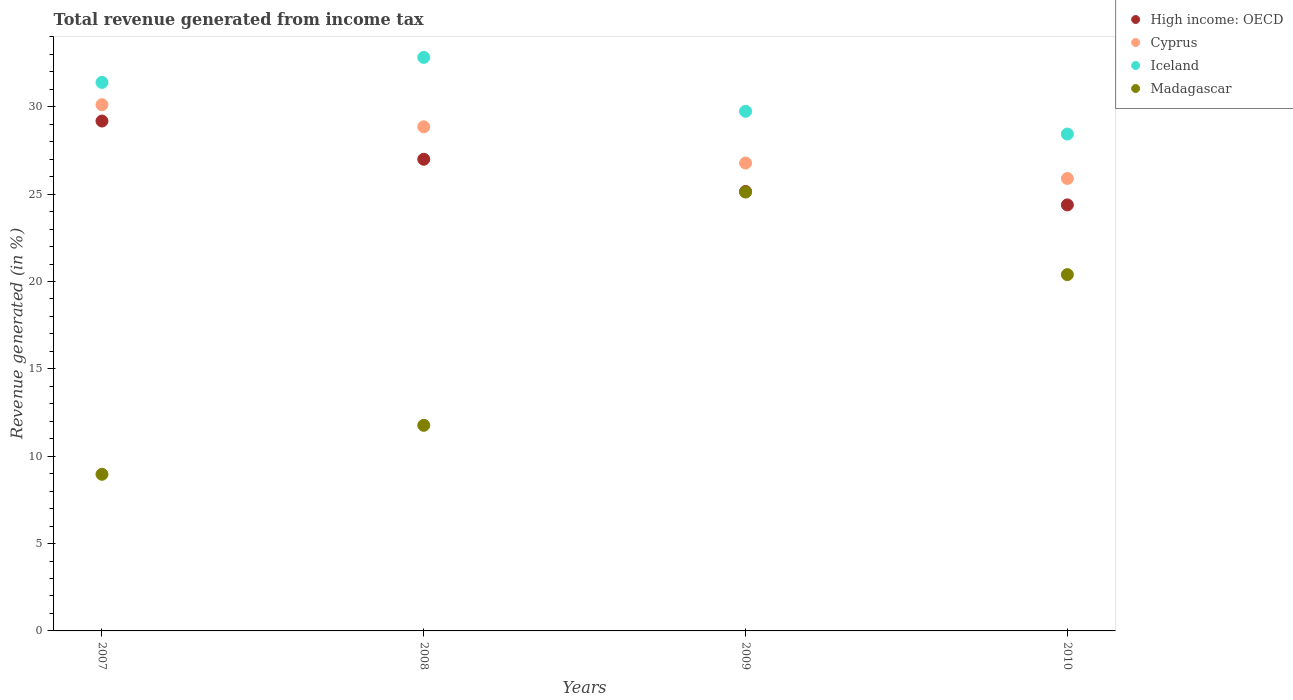Is the number of dotlines equal to the number of legend labels?
Offer a terse response. Yes. What is the total revenue generated in Cyprus in 2009?
Your response must be concise. 26.78. Across all years, what is the maximum total revenue generated in High income: OECD?
Provide a short and direct response. 29.19. Across all years, what is the minimum total revenue generated in High income: OECD?
Give a very brief answer. 24.39. In which year was the total revenue generated in Iceland maximum?
Provide a succinct answer. 2008. What is the total total revenue generated in Iceland in the graph?
Make the answer very short. 122.41. What is the difference between the total revenue generated in Cyprus in 2007 and that in 2010?
Offer a terse response. 4.22. What is the difference between the total revenue generated in High income: OECD in 2009 and the total revenue generated in Iceland in 2007?
Provide a short and direct response. -6.24. What is the average total revenue generated in Iceland per year?
Keep it short and to the point. 30.6. In the year 2010, what is the difference between the total revenue generated in Madagascar and total revenue generated in High income: OECD?
Your answer should be compact. -3.99. What is the ratio of the total revenue generated in Cyprus in 2007 to that in 2010?
Provide a short and direct response. 1.16. Is the total revenue generated in Iceland in 2007 less than that in 2010?
Ensure brevity in your answer.  No. What is the difference between the highest and the second highest total revenue generated in Madagascar?
Offer a terse response. 4.73. What is the difference between the highest and the lowest total revenue generated in Madagascar?
Offer a terse response. 16.16. Is the sum of the total revenue generated in Iceland in 2009 and 2010 greater than the maximum total revenue generated in Cyprus across all years?
Make the answer very short. Yes. How many dotlines are there?
Provide a short and direct response. 4. How many years are there in the graph?
Your answer should be very brief. 4. What is the difference between two consecutive major ticks on the Y-axis?
Provide a short and direct response. 5. Are the values on the major ticks of Y-axis written in scientific E-notation?
Ensure brevity in your answer.  No. Does the graph contain any zero values?
Your response must be concise. No. How many legend labels are there?
Provide a succinct answer. 4. How are the legend labels stacked?
Keep it short and to the point. Vertical. What is the title of the graph?
Give a very brief answer. Total revenue generated from income tax. Does "Namibia" appear as one of the legend labels in the graph?
Offer a terse response. No. What is the label or title of the X-axis?
Your response must be concise. Years. What is the label or title of the Y-axis?
Offer a very short reply. Revenue generated (in %). What is the Revenue generated (in %) in High income: OECD in 2007?
Offer a terse response. 29.19. What is the Revenue generated (in %) in Cyprus in 2007?
Provide a short and direct response. 30.12. What is the Revenue generated (in %) in Iceland in 2007?
Provide a short and direct response. 31.4. What is the Revenue generated (in %) in Madagascar in 2007?
Keep it short and to the point. 8.97. What is the Revenue generated (in %) of High income: OECD in 2008?
Offer a terse response. 27. What is the Revenue generated (in %) of Cyprus in 2008?
Your answer should be compact. 28.86. What is the Revenue generated (in %) in Iceland in 2008?
Provide a succinct answer. 32.83. What is the Revenue generated (in %) of Madagascar in 2008?
Your response must be concise. 11.77. What is the Revenue generated (in %) in High income: OECD in 2009?
Provide a succinct answer. 25.15. What is the Revenue generated (in %) in Cyprus in 2009?
Offer a terse response. 26.78. What is the Revenue generated (in %) in Iceland in 2009?
Your answer should be compact. 29.74. What is the Revenue generated (in %) of Madagascar in 2009?
Give a very brief answer. 25.12. What is the Revenue generated (in %) of High income: OECD in 2010?
Your answer should be compact. 24.39. What is the Revenue generated (in %) in Cyprus in 2010?
Keep it short and to the point. 25.9. What is the Revenue generated (in %) of Iceland in 2010?
Make the answer very short. 28.44. What is the Revenue generated (in %) of Madagascar in 2010?
Your response must be concise. 20.39. Across all years, what is the maximum Revenue generated (in %) in High income: OECD?
Give a very brief answer. 29.19. Across all years, what is the maximum Revenue generated (in %) in Cyprus?
Give a very brief answer. 30.12. Across all years, what is the maximum Revenue generated (in %) of Iceland?
Provide a succinct answer. 32.83. Across all years, what is the maximum Revenue generated (in %) of Madagascar?
Make the answer very short. 25.12. Across all years, what is the minimum Revenue generated (in %) in High income: OECD?
Provide a short and direct response. 24.39. Across all years, what is the minimum Revenue generated (in %) of Cyprus?
Provide a succinct answer. 25.9. Across all years, what is the minimum Revenue generated (in %) of Iceland?
Provide a short and direct response. 28.44. Across all years, what is the minimum Revenue generated (in %) of Madagascar?
Your response must be concise. 8.97. What is the total Revenue generated (in %) in High income: OECD in the graph?
Offer a very short reply. 105.72. What is the total Revenue generated (in %) in Cyprus in the graph?
Offer a terse response. 111.66. What is the total Revenue generated (in %) of Iceland in the graph?
Provide a short and direct response. 122.41. What is the total Revenue generated (in %) in Madagascar in the graph?
Offer a terse response. 66.25. What is the difference between the Revenue generated (in %) in High income: OECD in 2007 and that in 2008?
Make the answer very short. 2.19. What is the difference between the Revenue generated (in %) in Cyprus in 2007 and that in 2008?
Make the answer very short. 1.27. What is the difference between the Revenue generated (in %) in Iceland in 2007 and that in 2008?
Offer a very short reply. -1.43. What is the difference between the Revenue generated (in %) of Madagascar in 2007 and that in 2008?
Your answer should be compact. -2.8. What is the difference between the Revenue generated (in %) in High income: OECD in 2007 and that in 2009?
Give a very brief answer. 4.03. What is the difference between the Revenue generated (in %) of Cyprus in 2007 and that in 2009?
Make the answer very short. 3.34. What is the difference between the Revenue generated (in %) of Iceland in 2007 and that in 2009?
Your answer should be very brief. 1.65. What is the difference between the Revenue generated (in %) in Madagascar in 2007 and that in 2009?
Your answer should be compact. -16.16. What is the difference between the Revenue generated (in %) in High income: OECD in 2007 and that in 2010?
Provide a short and direct response. 4.8. What is the difference between the Revenue generated (in %) in Cyprus in 2007 and that in 2010?
Give a very brief answer. 4.22. What is the difference between the Revenue generated (in %) of Iceland in 2007 and that in 2010?
Give a very brief answer. 2.96. What is the difference between the Revenue generated (in %) of Madagascar in 2007 and that in 2010?
Make the answer very short. -11.43. What is the difference between the Revenue generated (in %) in High income: OECD in 2008 and that in 2009?
Keep it short and to the point. 1.84. What is the difference between the Revenue generated (in %) of Cyprus in 2008 and that in 2009?
Provide a short and direct response. 2.07. What is the difference between the Revenue generated (in %) in Iceland in 2008 and that in 2009?
Keep it short and to the point. 3.08. What is the difference between the Revenue generated (in %) in Madagascar in 2008 and that in 2009?
Your answer should be compact. -13.35. What is the difference between the Revenue generated (in %) in High income: OECD in 2008 and that in 2010?
Ensure brevity in your answer.  2.61. What is the difference between the Revenue generated (in %) of Cyprus in 2008 and that in 2010?
Provide a succinct answer. 2.96. What is the difference between the Revenue generated (in %) in Iceland in 2008 and that in 2010?
Your answer should be very brief. 4.39. What is the difference between the Revenue generated (in %) of Madagascar in 2008 and that in 2010?
Your answer should be very brief. -8.63. What is the difference between the Revenue generated (in %) in High income: OECD in 2009 and that in 2010?
Offer a terse response. 0.77. What is the difference between the Revenue generated (in %) in Cyprus in 2009 and that in 2010?
Provide a succinct answer. 0.89. What is the difference between the Revenue generated (in %) in Iceland in 2009 and that in 2010?
Your answer should be very brief. 1.3. What is the difference between the Revenue generated (in %) in Madagascar in 2009 and that in 2010?
Provide a short and direct response. 4.73. What is the difference between the Revenue generated (in %) of High income: OECD in 2007 and the Revenue generated (in %) of Cyprus in 2008?
Give a very brief answer. 0.33. What is the difference between the Revenue generated (in %) in High income: OECD in 2007 and the Revenue generated (in %) in Iceland in 2008?
Provide a succinct answer. -3.64. What is the difference between the Revenue generated (in %) of High income: OECD in 2007 and the Revenue generated (in %) of Madagascar in 2008?
Provide a short and direct response. 17.42. What is the difference between the Revenue generated (in %) of Cyprus in 2007 and the Revenue generated (in %) of Iceland in 2008?
Give a very brief answer. -2.71. What is the difference between the Revenue generated (in %) of Cyprus in 2007 and the Revenue generated (in %) of Madagascar in 2008?
Provide a short and direct response. 18.35. What is the difference between the Revenue generated (in %) in Iceland in 2007 and the Revenue generated (in %) in Madagascar in 2008?
Make the answer very short. 19.63. What is the difference between the Revenue generated (in %) in High income: OECD in 2007 and the Revenue generated (in %) in Cyprus in 2009?
Ensure brevity in your answer.  2.4. What is the difference between the Revenue generated (in %) in High income: OECD in 2007 and the Revenue generated (in %) in Iceland in 2009?
Your answer should be very brief. -0.56. What is the difference between the Revenue generated (in %) of High income: OECD in 2007 and the Revenue generated (in %) of Madagascar in 2009?
Your answer should be compact. 4.06. What is the difference between the Revenue generated (in %) in Cyprus in 2007 and the Revenue generated (in %) in Iceland in 2009?
Make the answer very short. 0.38. What is the difference between the Revenue generated (in %) in Cyprus in 2007 and the Revenue generated (in %) in Madagascar in 2009?
Offer a terse response. 5. What is the difference between the Revenue generated (in %) of Iceland in 2007 and the Revenue generated (in %) of Madagascar in 2009?
Give a very brief answer. 6.28. What is the difference between the Revenue generated (in %) in High income: OECD in 2007 and the Revenue generated (in %) in Cyprus in 2010?
Provide a succinct answer. 3.29. What is the difference between the Revenue generated (in %) in High income: OECD in 2007 and the Revenue generated (in %) in Iceland in 2010?
Provide a short and direct response. 0.74. What is the difference between the Revenue generated (in %) in High income: OECD in 2007 and the Revenue generated (in %) in Madagascar in 2010?
Ensure brevity in your answer.  8.79. What is the difference between the Revenue generated (in %) of Cyprus in 2007 and the Revenue generated (in %) of Iceland in 2010?
Provide a short and direct response. 1.68. What is the difference between the Revenue generated (in %) of Cyprus in 2007 and the Revenue generated (in %) of Madagascar in 2010?
Make the answer very short. 9.73. What is the difference between the Revenue generated (in %) of Iceland in 2007 and the Revenue generated (in %) of Madagascar in 2010?
Your answer should be very brief. 11. What is the difference between the Revenue generated (in %) of High income: OECD in 2008 and the Revenue generated (in %) of Cyprus in 2009?
Your answer should be compact. 0.21. What is the difference between the Revenue generated (in %) of High income: OECD in 2008 and the Revenue generated (in %) of Iceland in 2009?
Offer a very short reply. -2.75. What is the difference between the Revenue generated (in %) of High income: OECD in 2008 and the Revenue generated (in %) of Madagascar in 2009?
Give a very brief answer. 1.88. What is the difference between the Revenue generated (in %) of Cyprus in 2008 and the Revenue generated (in %) of Iceland in 2009?
Offer a terse response. -0.89. What is the difference between the Revenue generated (in %) of Cyprus in 2008 and the Revenue generated (in %) of Madagascar in 2009?
Your response must be concise. 3.73. What is the difference between the Revenue generated (in %) of Iceland in 2008 and the Revenue generated (in %) of Madagascar in 2009?
Your answer should be very brief. 7.71. What is the difference between the Revenue generated (in %) in High income: OECD in 2008 and the Revenue generated (in %) in Cyprus in 2010?
Keep it short and to the point. 1.1. What is the difference between the Revenue generated (in %) of High income: OECD in 2008 and the Revenue generated (in %) of Iceland in 2010?
Your answer should be compact. -1.44. What is the difference between the Revenue generated (in %) of High income: OECD in 2008 and the Revenue generated (in %) of Madagascar in 2010?
Make the answer very short. 6.6. What is the difference between the Revenue generated (in %) of Cyprus in 2008 and the Revenue generated (in %) of Iceland in 2010?
Your answer should be very brief. 0.41. What is the difference between the Revenue generated (in %) in Cyprus in 2008 and the Revenue generated (in %) in Madagascar in 2010?
Offer a very short reply. 8.46. What is the difference between the Revenue generated (in %) of Iceland in 2008 and the Revenue generated (in %) of Madagascar in 2010?
Offer a very short reply. 12.43. What is the difference between the Revenue generated (in %) of High income: OECD in 2009 and the Revenue generated (in %) of Cyprus in 2010?
Your answer should be compact. -0.74. What is the difference between the Revenue generated (in %) in High income: OECD in 2009 and the Revenue generated (in %) in Iceland in 2010?
Provide a short and direct response. -3.29. What is the difference between the Revenue generated (in %) in High income: OECD in 2009 and the Revenue generated (in %) in Madagascar in 2010?
Give a very brief answer. 4.76. What is the difference between the Revenue generated (in %) of Cyprus in 2009 and the Revenue generated (in %) of Iceland in 2010?
Offer a very short reply. -1.66. What is the difference between the Revenue generated (in %) of Cyprus in 2009 and the Revenue generated (in %) of Madagascar in 2010?
Provide a succinct answer. 6.39. What is the difference between the Revenue generated (in %) of Iceland in 2009 and the Revenue generated (in %) of Madagascar in 2010?
Offer a terse response. 9.35. What is the average Revenue generated (in %) of High income: OECD per year?
Make the answer very short. 26.43. What is the average Revenue generated (in %) of Cyprus per year?
Your response must be concise. 27.91. What is the average Revenue generated (in %) of Iceland per year?
Offer a terse response. 30.6. What is the average Revenue generated (in %) of Madagascar per year?
Ensure brevity in your answer.  16.56. In the year 2007, what is the difference between the Revenue generated (in %) of High income: OECD and Revenue generated (in %) of Cyprus?
Offer a very short reply. -0.93. In the year 2007, what is the difference between the Revenue generated (in %) in High income: OECD and Revenue generated (in %) in Iceland?
Your answer should be compact. -2.21. In the year 2007, what is the difference between the Revenue generated (in %) in High income: OECD and Revenue generated (in %) in Madagascar?
Keep it short and to the point. 20.22. In the year 2007, what is the difference between the Revenue generated (in %) in Cyprus and Revenue generated (in %) in Iceland?
Keep it short and to the point. -1.28. In the year 2007, what is the difference between the Revenue generated (in %) in Cyprus and Revenue generated (in %) in Madagascar?
Provide a short and direct response. 21.15. In the year 2007, what is the difference between the Revenue generated (in %) in Iceland and Revenue generated (in %) in Madagascar?
Offer a terse response. 22.43. In the year 2008, what is the difference between the Revenue generated (in %) in High income: OECD and Revenue generated (in %) in Cyprus?
Your answer should be compact. -1.86. In the year 2008, what is the difference between the Revenue generated (in %) in High income: OECD and Revenue generated (in %) in Iceland?
Provide a short and direct response. -5.83. In the year 2008, what is the difference between the Revenue generated (in %) of High income: OECD and Revenue generated (in %) of Madagascar?
Your response must be concise. 15.23. In the year 2008, what is the difference between the Revenue generated (in %) of Cyprus and Revenue generated (in %) of Iceland?
Ensure brevity in your answer.  -3.97. In the year 2008, what is the difference between the Revenue generated (in %) of Cyprus and Revenue generated (in %) of Madagascar?
Your answer should be very brief. 17.09. In the year 2008, what is the difference between the Revenue generated (in %) in Iceland and Revenue generated (in %) in Madagascar?
Keep it short and to the point. 21.06. In the year 2009, what is the difference between the Revenue generated (in %) in High income: OECD and Revenue generated (in %) in Cyprus?
Offer a very short reply. -1.63. In the year 2009, what is the difference between the Revenue generated (in %) of High income: OECD and Revenue generated (in %) of Iceland?
Ensure brevity in your answer.  -4.59. In the year 2009, what is the difference between the Revenue generated (in %) of High income: OECD and Revenue generated (in %) of Madagascar?
Your response must be concise. 0.03. In the year 2009, what is the difference between the Revenue generated (in %) of Cyprus and Revenue generated (in %) of Iceland?
Offer a terse response. -2.96. In the year 2009, what is the difference between the Revenue generated (in %) of Cyprus and Revenue generated (in %) of Madagascar?
Keep it short and to the point. 1.66. In the year 2009, what is the difference between the Revenue generated (in %) in Iceland and Revenue generated (in %) in Madagascar?
Provide a short and direct response. 4.62. In the year 2010, what is the difference between the Revenue generated (in %) in High income: OECD and Revenue generated (in %) in Cyprus?
Your answer should be very brief. -1.51. In the year 2010, what is the difference between the Revenue generated (in %) of High income: OECD and Revenue generated (in %) of Iceland?
Give a very brief answer. -4.06. In the year 2010, what is the difference between the Revenue generated (in %) of High income: OECD and Revenue generated (in %) of Madagascar?
Make the answer very short. 3.99. In the year 2010, what is the difference between the Revenue generated (in %) in Cyprus and Revenue generated (in %) in Iceland?
Your response must be concise. -2.54. In the year 2010, what is the difference between the Revenue generated (in %) in Cyprus and Revenue generated (in %) in Madagascar?
Offer a terse response. 5.5. In the year 2010, what is the difference between the Revenue generated (in %) of Iceland and Revenue generated (in %) of Madagascar?
Provide a short and direct response. 8.05. What is the ratio of the Revenue generated (in %) in High income: OECD in 2007 to that in 2008?
Provide a short and direct response. 1.08. What is the ratio of the Revenue generated (in %) of Cyprus in 2007 to that in 2008?
Ensure brevity in your answer.  1.04. What is the ratio of the Revenue generated (in %) in Iceland in 2007 to that in 2008?
Make the answer very short. 0.96. What is the ratio of the Revenue generated (in %) in Madagascar in 2007 to that in 2008?
Keep it short and to the point. 0.76. What is the ratio of the Revenue generated (in %) of High income: OECD in 2007 to that in 2009?
Provide a short and direct response. 1.16. What is the ratio of the Revenue generated (in %) in Cyprus in 2007 to that in 2009?
Provide a succinct answer. 1.12. What is the ratio of the Revenue generated (in %) in Iceland in 2007 to that in 2009?
Give a very brief answer. 1.06. What is the ratio of the Revenue generated (in %) of Madagascar in 2007 to that in 2009?
Give a very brief answer. 0.36. What is the ratio of the Revenue generated (in %) in High income: OECD in 2007 to that in 2010?
Provide a succinct answer. 1.2. What is the ratio of the Revenue generated (in %) in Cyprus in 2007 to that in 2010?
Keep it short and to the point. 1.16. What is the ratio of the Revenue generated (in %) in Iceland in 2007 to that in 2010?
Provide a succinct answer. 1.1. What is the ratio of the Revenue generated (in %) in Madagascar in 2007 to that in 2010?
Provide a short and direct response. 0.44. What is the ratio of the Revenue generated (in %) of High income: OECD in 2008 to that in 2009?
Provide a succinct answer. 1.07. What is the ratio of the Revenue generated (in %) of Cyprus in 2008 to that in 2009?
Keep it short and to the point. 1.08. What is the ratio of the Revenue generated (in %) in Iceland in 2008 to that in 2009?
Give a very brief answer. 1.1. What is the ratio of the Revenue generated (in %) in Madagascar in 2008 to that in 2009?
Your answer should be very brief. 0.47. What is the ratio of the Revenue generated (in %) in High income: OECD in 2008 to that in 2010?
Make the answer very short. 1.11. What is the ratio of the Revenue generated (in %) of Cyprus in 2008 to that in 2010?
Provide a succinct answer. 1.11. What is the ratio of the Revenue generated (in %) in Iceland in 2008 to that in 2010?
Your response must be concise. 1.15. What is the ratio of the Revenue generated (in %) of Madagascar in 2008 to that in 2010?
Your answer should be compact. 0.58. What is the ratio of the Revenue generated (in %) in High income: OECD in 2009 to that in 2010?
Provide a succinct answer. 1.03. What is the ratio of the Revenue generated (in %) in Cyprus in 2009 to that in 2010?
Your answer should be compact. 1.03. What is the ratio of the Revenue generated (in %) in Iceland in 2009 to that in 2010?
Provide a short and direct response. 1.05. What is the ratio of the Revenue generated (in %) in Madagascar in 2009 to that in 2010?
Your answer should be very brief. 1.23. What is the difference between the highest and the second highest Revenue generated (in %) of High income: OECD?
Offer a terse response. 2.19. What is the difference between the highest and the second highest Revenue generated (in %) of Cyprus?
Your response must be concise. 1.27. What is the difference between the highest and the second highest Revenue generated (in %) of Iceland?
Provide a short and direct response. 1.43. What is the difference between the highest and the second highest Revenue generated (in %) in Madagascar?
Make the answer very short. 4.73. What is the difference between the highest and the lowest Revenue generated (in %) in High income: OECD?
Your response must be concise. 4.8. What is the difference between the highest and the lowest Revenue generated (in %) of Cyprus?
Your answer should be very brief. 4.22. What is the difference between the highest and the lowest Revenue generated (in %) of Iceland?
Provide a succinct answer. 4.39. What is the difference between the highest and the lowest Revenue generated (in %) of Madagascar?
Offer a terse response. 16.16. 